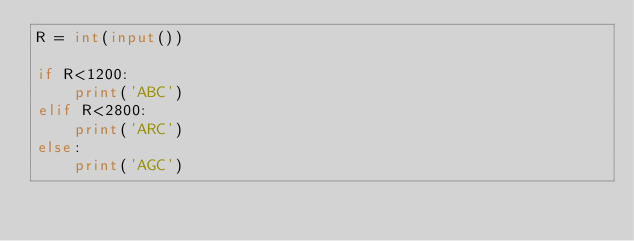<code> <loc_0><loc_0><loc_500><loc_500><_Python_>R = int(input())

if R<1200:
    print('ABC')
elif R<2800:
    print('ARC')
else:
    print('AGC')</code> 